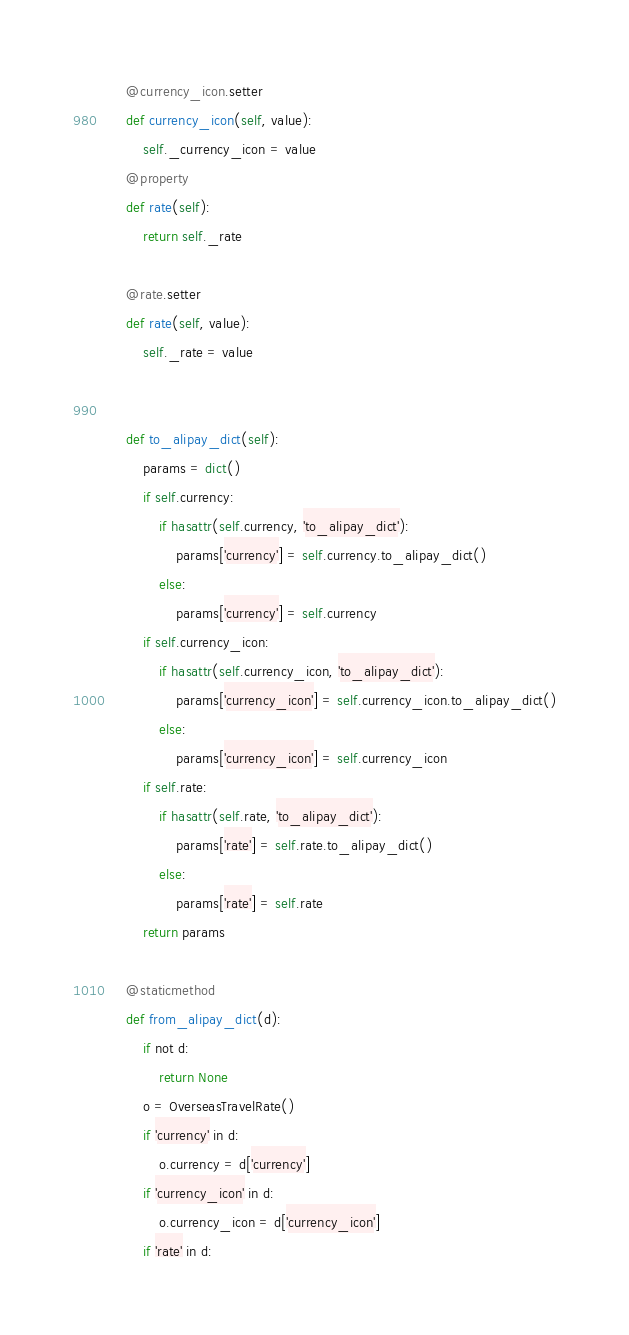Convert code to text. <code><loc_0><loc_0><loc_500><loc_500><_Python_>    @currency_icon.setter
    def currency_icon(self, value):
        self._currency_icon = value
    @property
    def rate(self):
        return self._rate

    @rate.setter
    def rate(self, value):
        self._rate = value


    def to_alipay_dict(self):
        params = dict()
        if self.currency:
            if hasattr(self.currency, 'to_alipay_dict'):
                params['currency'] = self.currency.to_alipay_dict()
            else:
                params['currency'] = self.currency
        if self.currency_icon:
            if hasattr(self.currency_icon, 'to_alipay_dict'):
                params['currency_icon'] = self.currency_icon.to_alipay_dict()
            else:
                params['currency_icon'] = self.currency_icon
        if self.rate:
            if hasattr(self.rate, 'to_alipay_dict'):
                params['rate'] = self.rate.to_alipay_dict()
            else:
                params['rate'] = self.rate
        return params

    @staticmethod
    def from_alipay_dict(d):
        if not d:
            return None
        o = OverseasTravelRate()
        if 'currency' in d:
            o.currency = d['currency']
        if 'currency_icon' in d:
            o.currency_icon = d['currency_icon']
        if 'rate' in d:</code> 